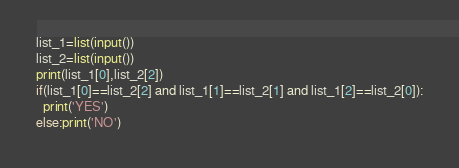Convert code to text. <code><loc_0><loc_0><loc_500><loc_500><_Python_>list_1=list(input())
list_2=list(input())
print(list_1[0],list_2[2])
if(list_1[0]==list_2[2] and list_1[1]==list_2[1] and list_1[2]==list_2[0]):
  print('YES')
else:print('NO')</code> 